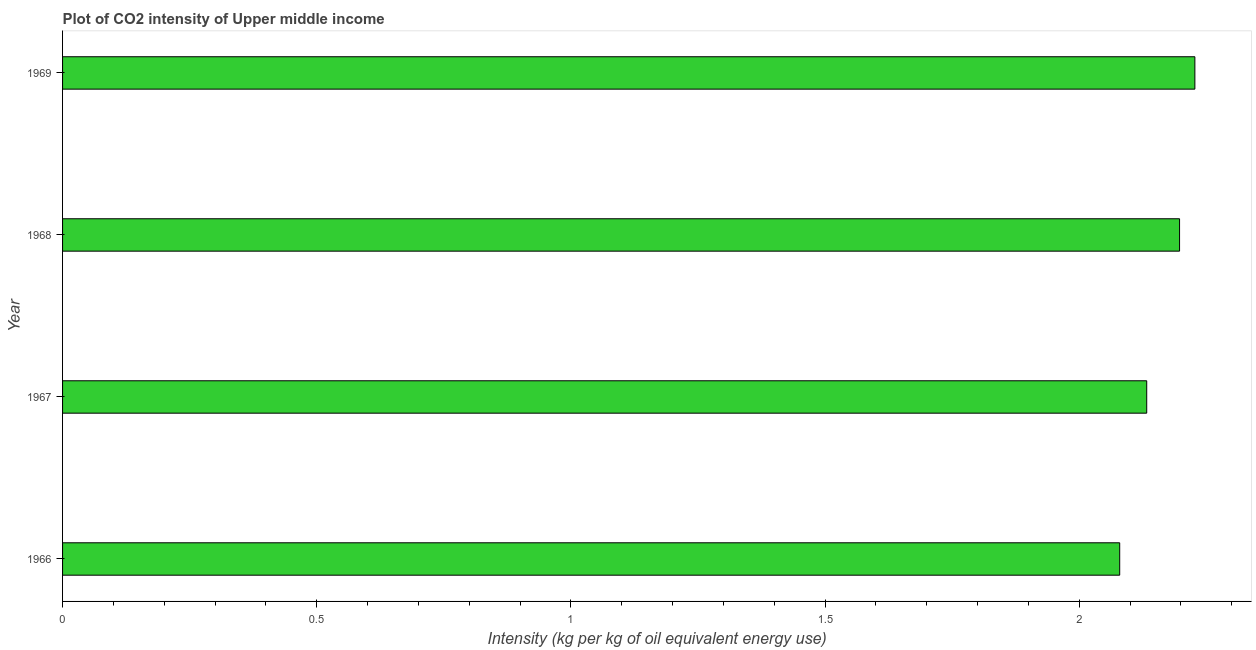Does the graph contain any zero values?
Your answer should be very brief. No. What is the title of the graph?
Keep it short and to the point. Plot of CO2 intensity of Upper middle income. What is the label or title of the X-axis?
Keep it short and to the point. Intensity (kg per kg of oil equivalent energy use). What is the label or title of the Y-axis?
Offer a very short reply. Year. What is the co2 intensity in 1968?
Your response must be concise. 2.2. Across all years, what is the maximum co2 intensity?
Provide a succinct answer. 2.23. Across all years, what is the minimum co2 intensity?
Give a very brief answer. 2.08. In which year was the co2 intensity maximum?
Ensure brevity in your answer.  1969. In which year was the co2 intensity minimum?
Ensure brevity in your answer.  1966. What is the sum of the co2 intensity?
Offer a very short reply. 8.64. What is the difference between the co2 intensity in 1968 and 1969?
Make the answer very short. -0.03. What is the average co2 intensity per year?
Give a very brief answer. 2.16. What is the median co2 intensity?
Give a very brief answer. 2.17. Do a majority of the years between 1966 and 1967 (inclusive) have co2 intensity greater than 0.3 kg?
Give a very brief answer. Yes. Is the co2 intensity in 1966 less than that in 1968?
Give a very brief answer. Yes. How many bars are there?
Offer a terse response. 4. Are all the bars in the graph horizontal?
Provide a short and direct response. Yes. What is the Intensity (kg per kg of oil equivalent energy use) in 1966?
Provide a short and direct response. 2.08. What is the Intensity (kg per kg of oil equivalent energy use) of 1967?
Offer a terse response. 2.13. What is the Intensity (kg per kg of oil equivalent energy use) of 1968?
Your answer should be compact. 2.2. What is the Intensity (kg per kg of oil equivalent energy use) in 1969?
Keep it short and to the point. 2.23. What is the difference between the Intensity (kg per kg of oil equivalent energy use) in 1966 and 1967?
Offer a very short reply. -0.05. What is the difference between the Intensity (kg per kg of oil equivalent energy use) in 1966 and 1968?
Your response must be concise. -0.12. What is the difference between the Intensity (kg per kg of oil equivalent energy use) in 1966 and 1969?
Your answer should be very brief. -0.15. What is the difference between the Intensity (kg per kg of oil equivalent energy use) in 1967 and 1968?
Your answer should be very brief. -0.06. What is the difference between the Intensity (kg per kg of oil equivalent energy use) in 1967 and 1969?
Your response must be concise. -0.09. What is the difference between the Intensity (kg per kg of oil equivalent energy use) in 1968 and 1969?
Your response must be concise. -0.03. What is the ratio of the Intensity (kg per kg of oil equivalent energy use) in 1966 to that in 1968?
Provide a succinct answer. 0.95. What is the ratio of the Intensity (kg per kg of oil equivalent energy use) in 1966 to that in 1969?
Keep it short and to the point. 0.93. What is the ratio of the Intensity (kg per kg of oil equivalent energy use) in 1968 to that in 1969?
Make the answer very short. 0.99. 